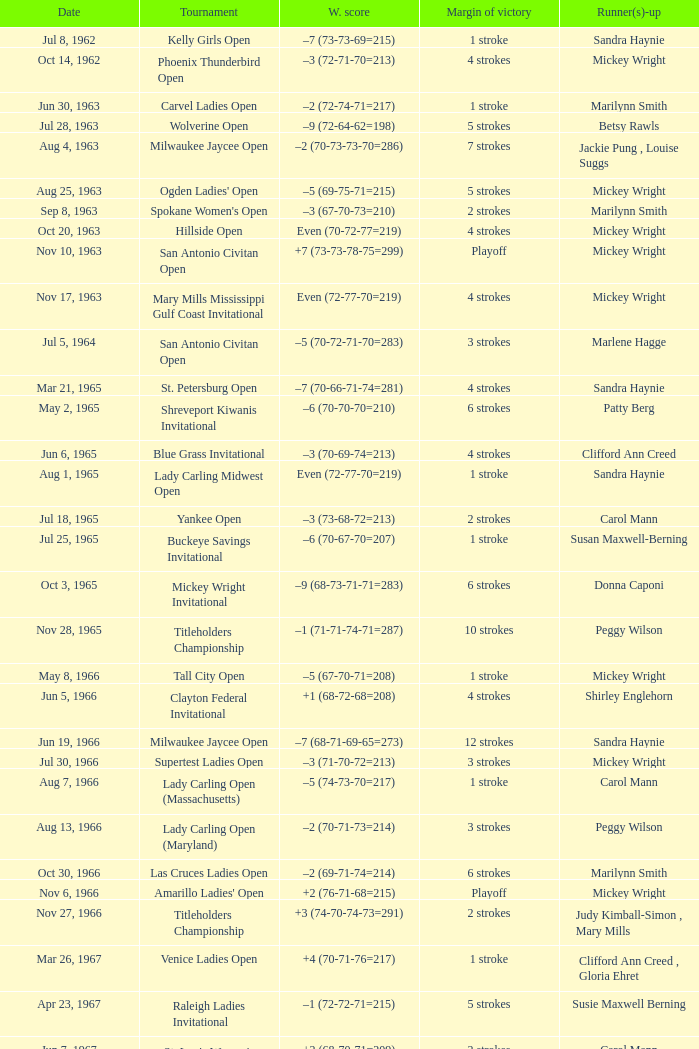What was the margin of victory on Apr 23, 1967? 5 strokes. 